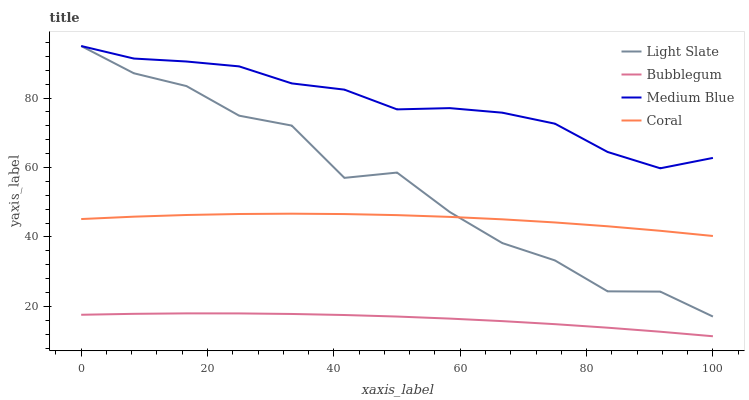Does Bubblegum have the minimum area under the curve?
Answer yes or no. Yes. Does Medium Blue have the maximum area under the curve?
Answer yes or no. Yes. Does Coral have the minimum area under the curve?
Answer yes or no. No. Does Coral have the maximum area under the curve?
Answer yes or no. No. Is Bubblegum the smoothest?
Answer yes or no. Yes. Is Light Slate the roughest?
Answer yes or no. Yes. Is Coral the smoothest?
Answer yes or no. No. Is Coral the roughest?
Answer yes or no. No. Does Coral have the lowest value?
Answer yes or no. No. Does Medium Blue have the highest value?
Answer yes or no. Yes. Does Coral have the highest value?
Answer yes or no. No. Is Coral less than Medium Blue?
Answer yes or no. Yes. Is Medium Blue greater than Coral?
Answer yes or no. Yes. Does Light Slate intersect Medium Blue?
Answer yes or no. Yes. Is Light Slate less than Medium Blue?
Answer yes or no. No. Is Light Slate greater than Medium Blue?
Answer yes or no. No. Does Coral intersect Medium Blue?
Answer yes or no. No. 